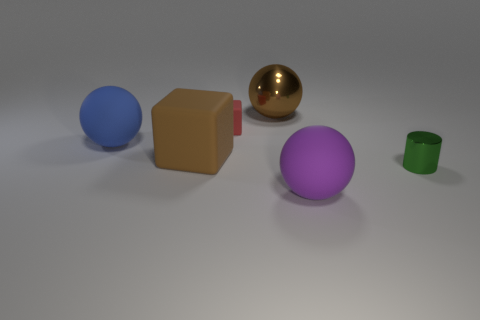Is the shape of the big brown object in front of the blue thing the same as  the small red rubber object?
Provide a short and direct response. Yes. What is the small object that is to the left of the big brown shiny object made of?
Make the answer very short. Rubber. What number of purple matte things are the same shape as the big metal thing?
Give a very brief answer. 1. What is the object that is to the right of the matte thing on the right side of the large metal ball made of?
Provide a succinct answer. Metal. What is the shape of the rubber thing that is the same color as the large metallic object?
Make the answer very short. Cube. Are there any things made of the same material as the tiny cylinder?
Your answer should be compact. Yes. The big purple thing is what shape?
Provide a succinct answer. Sphere. What number of large red cylinders are there?
Your answer should be very brief. 0. What is the color of the rubber cube to the left of the red object that is to the left of the tiny green shiny cylinder?
Provide a short and direct response. Brown. What color is the rubber block that is the same size as the purple object?
Make the answer very short. Brown. 